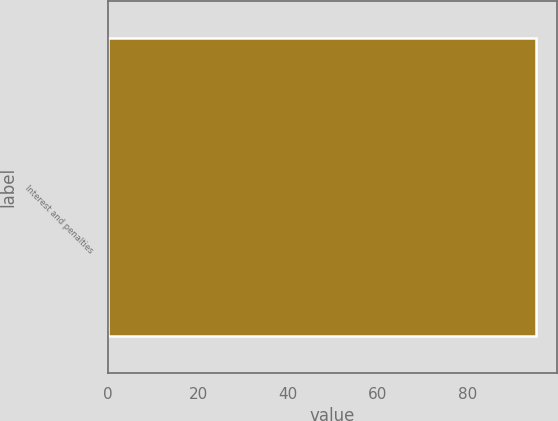Convert chart. <chart><loc_0><loc_0><loc_500><loc_500><bar_chart><fcel>Interest and penalties<nl><fcel>95<nl></chart> 